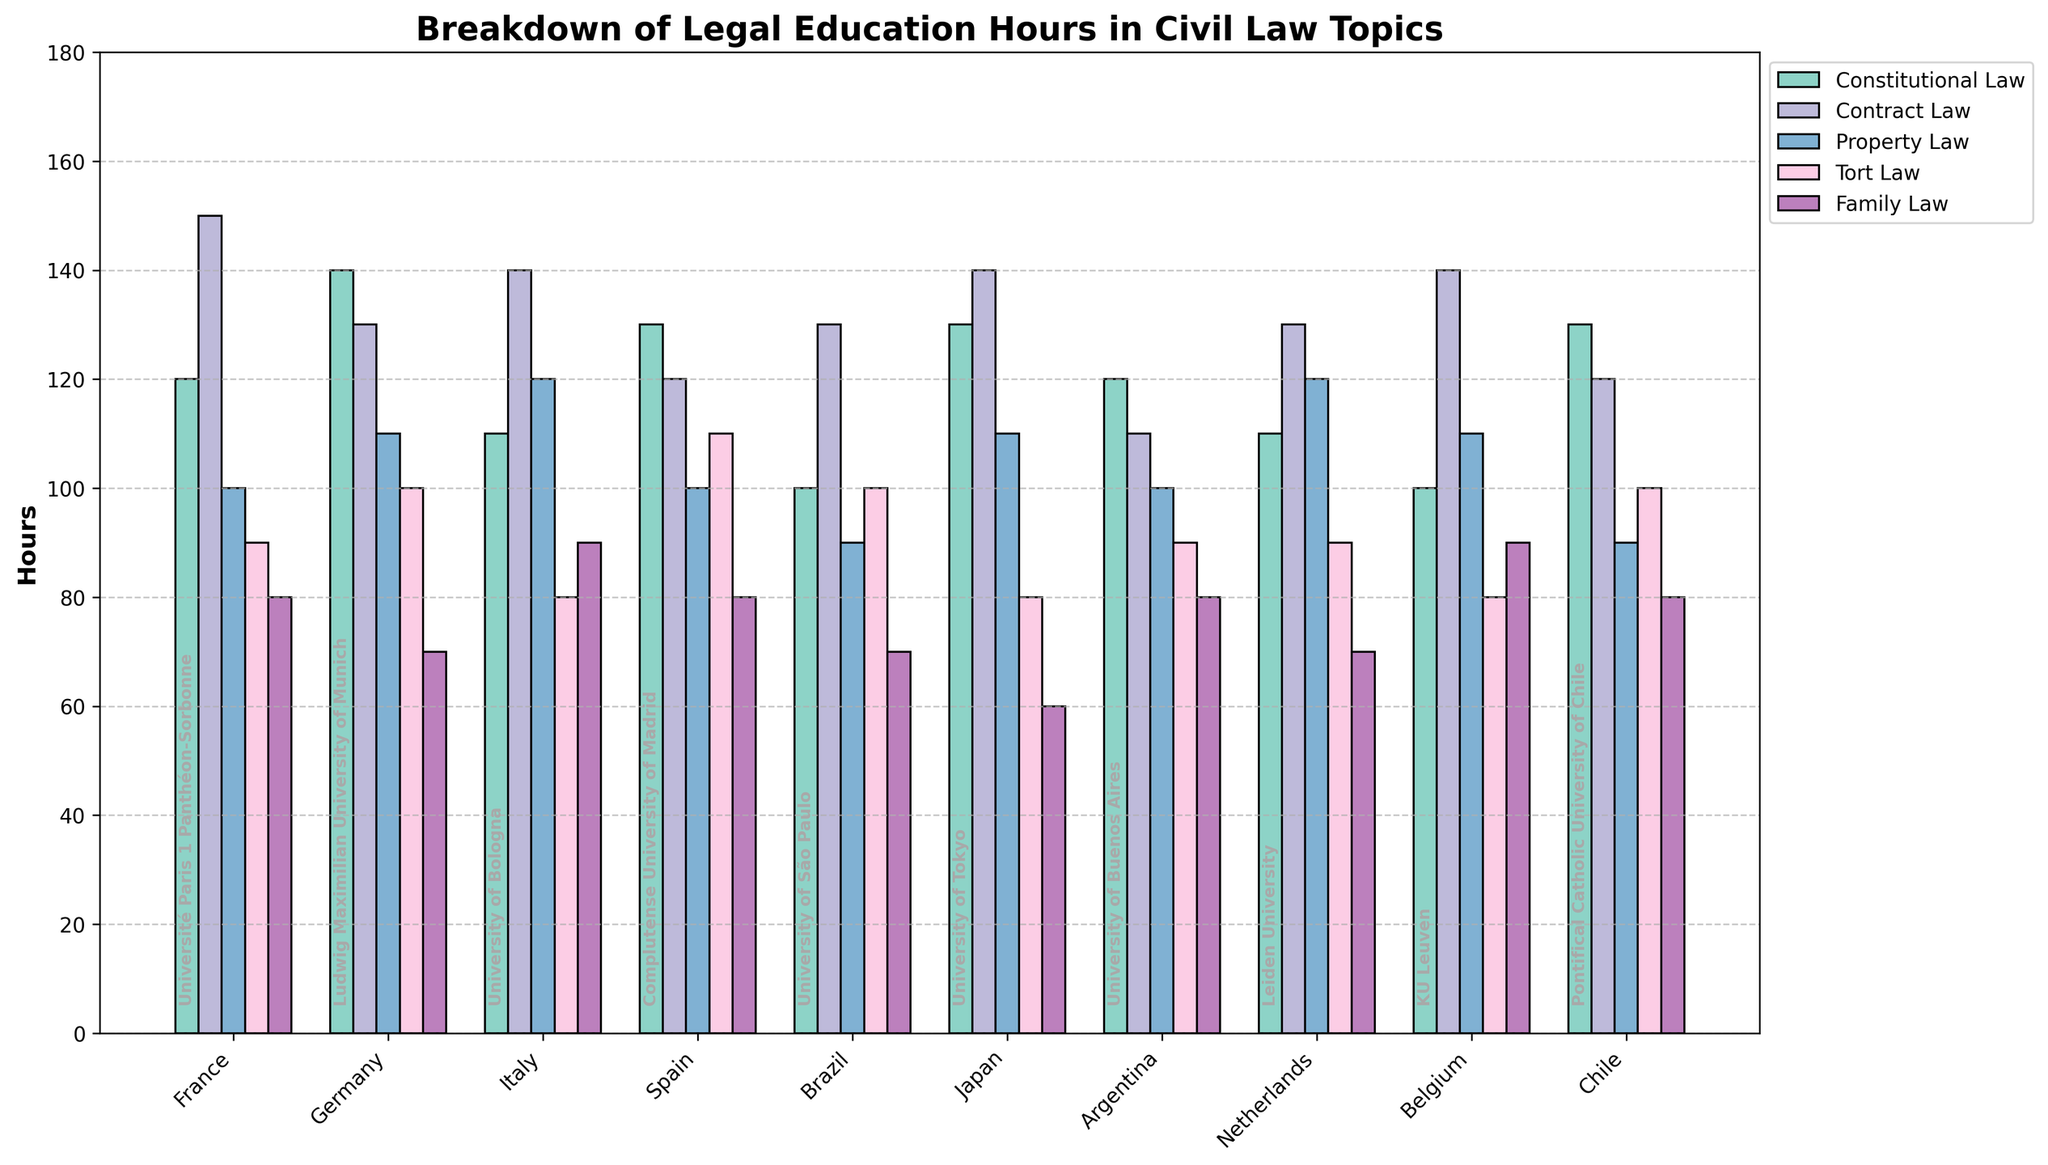Which university has the highest total hours devoted to civil law topics? Add up the hours for each university: Université Paris 1 Panthéon-Sorbonne = 120 + 150 + 100 + 90 + 80 = 540, Ludwig Maximilian University of Munich = 140 + 130 + 110 + 100 + 70 = 550, University of Bologna = 110 + 140 + 120 + 80 + 90 = 540, Complutense University of Madrid = 130 + 120 + 100 + 110 + 80 = 540, University of São Paulo = 100 + 130 + 90 + 100 + 70 = 490, University of Tokyo = 130 + 140 + 110 + 80 + 60 = 520, University of Buenos Aires = 120 + 110 + 100 + 90 + 80 = 500, Leiden University = 110 + 130 + 120 + 90 + 70 = 520, KU Leuven = 100 + 140 + 110 + 80 + 90 = 520, Pontifical Catholic University of Chile = 130 + 120 + 90 + 100 + 80 = 520. The highest is Ludwig Maximilian University of Munich with 550 hours.
Answer: Ludwig Maximilian University of Munich Which country has the lowest hours devoted to Family Law? Check the Family Law column for all countries: Université Paris 1 Panthéon-Sorbonne = 80, Ludwig Maximilian University of Munich = 70, University of Bologna = 90, Complutense University of Madrid = 80, University of São Paulo = 70, University of Tokyo = 60, University of Buenos Aires = 80, Leiden University = 70, KU Leuven = 90, Pontifical Catholic University of Chile = 80. The lowest is Japan with 60 hours.
Answer: Japan Compare the total hours devoted to Property Law between University of São Paulo and Leiden University. Which one has more hours and by how much? University of São Paulo has 90 hours and Leiden University has 120 hours devoted to Property Law. The difference is 120 - 90 = 30 hours, with Leiden University having more.
Answer: Leiden University, 30 hours What's the average number of hours devoted to Constitutional Law across all universities? Sum up the Constitutional Law hours: 120 + 140 + 110 + 130 + 100 + 130 + 120 + 110 + 100 + 130 = 1190. There are 10 universities, so average = 1190 / 10 = 119 hours.
Answer: 119 hours Which two universities have exactly the same number of total hours devoted to civil law topics and what is the total? Université Paris 1 Panthéon-Sorbonne and University of Bologna both have 540 hours. Validate by calculating total hours as follows: Université Paris 1 Panthéon-Sorbonne total = 540, University of Bologna total = 540.
Answer: Université Paris 1 Panthéon-Sorbonne and University of Bologna, 540 hours Among all the subjects, which one has the smallest range of hours devoted across all universities? Calculate the range for each subject: Constitutional Law range = 140 - 100 = 40, Contract Law range = 150 - 110 = 40, Property Law range = 120 - 90 = 30, Tort Law range = 110 - 80 = 30, Family Law range = 90 - 60 = 30. The smallest range is 30 hours, which is the same for Property Law, Tort Law, and Family Law.
Answer: Property Law, Tort Law, and Family Law Which university has the maximum hours for Contract Law and what are the hours? Compare Contract Law hours across universities: Université Paris 1 Panthéon-Sorbonne = 150, Ludwig Maximilian University of Munich = 130, University of Bologna = 140, Complutense University of Madrid = 120, University of São Paulo = 130, University of Tokyo = 140, University of Buenos Aires = 110, Leiden University = 130, KU Leuven = 140, Pontifical Catholic University of Chile = 120. The maximum is Université Paris 1 Panthéon-Sorbonne with 150 hours.
Answer: Université Paris 1 Panthéon-Sorbonne, 150 hours 